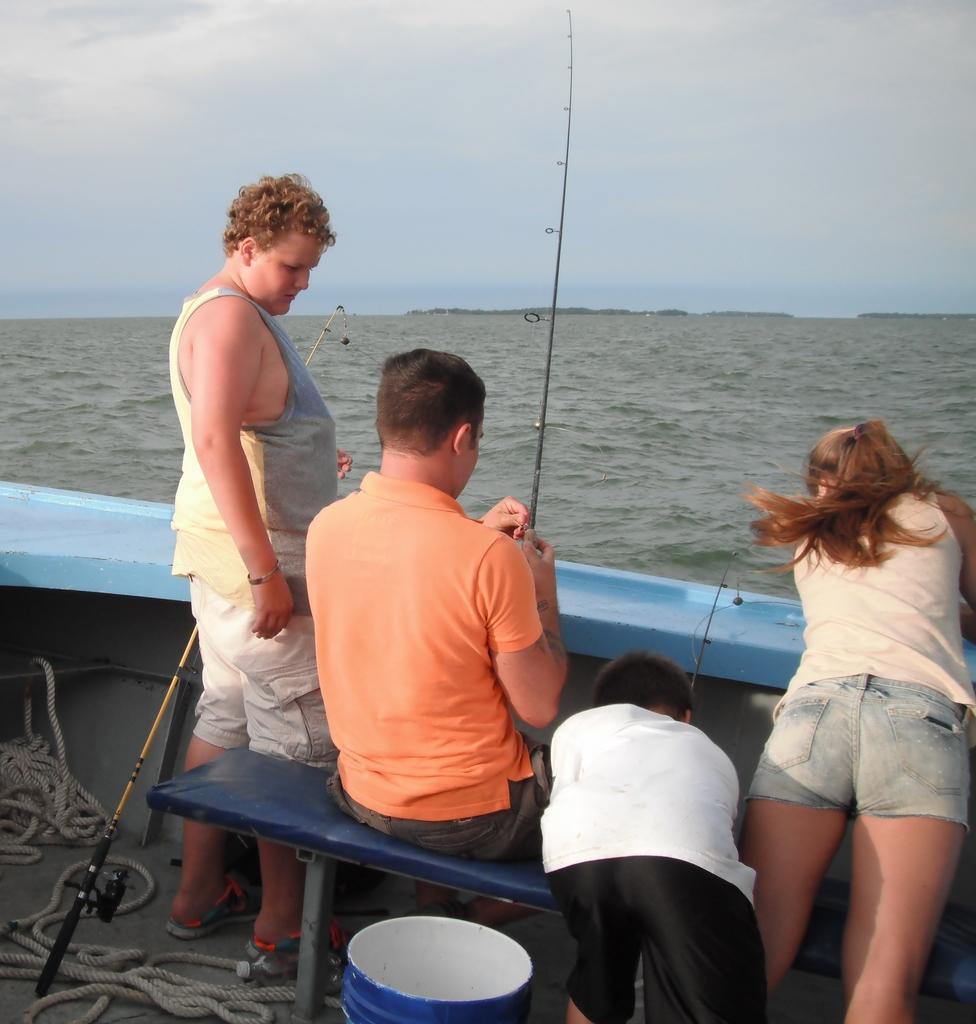How would you summarize this image in a sentence or two? In this picture I can see 4 persons in front who are on a thing and I see the ropes and a bucket in front. I see that the man in the middle is holding a fishing rod and I see another fishing rod on the left side of this image. In the background I see the water and the sky. 